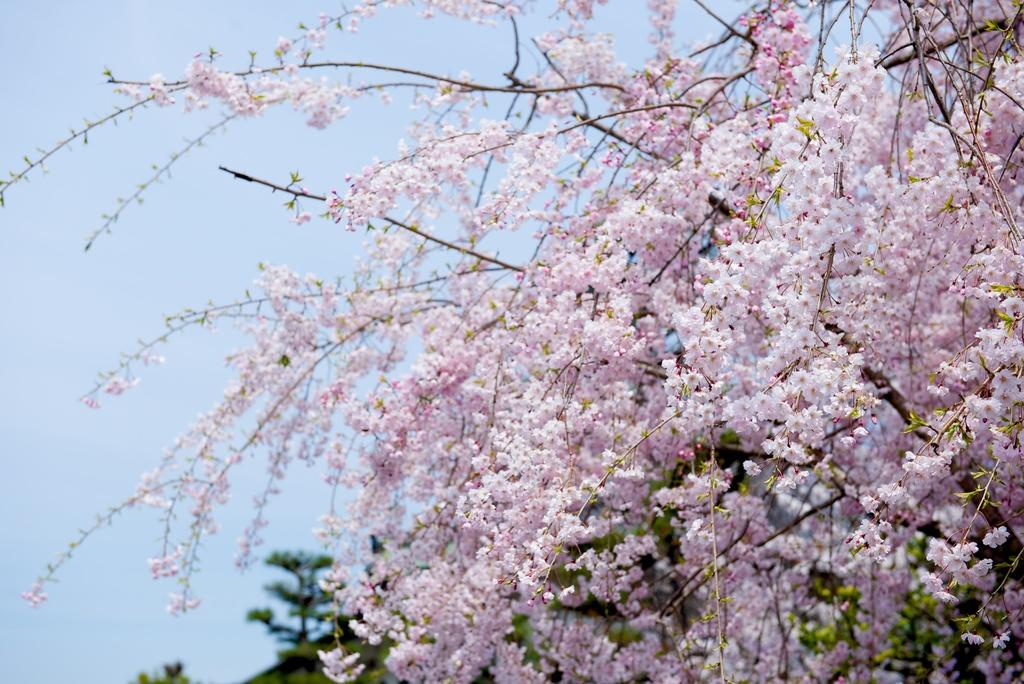What type of tree is present in the image? There is a tree with flowers in the image. What can be seen in the background of the image? There are trees and grass in the background of the image. What is visible in the sky in the image? The sky is visible in the background of the image. How is the background of the image depicted? The background of the image is blurred. What type of drink is being served by the representative on a bike in the image? There is no representative or bike present in the image. 